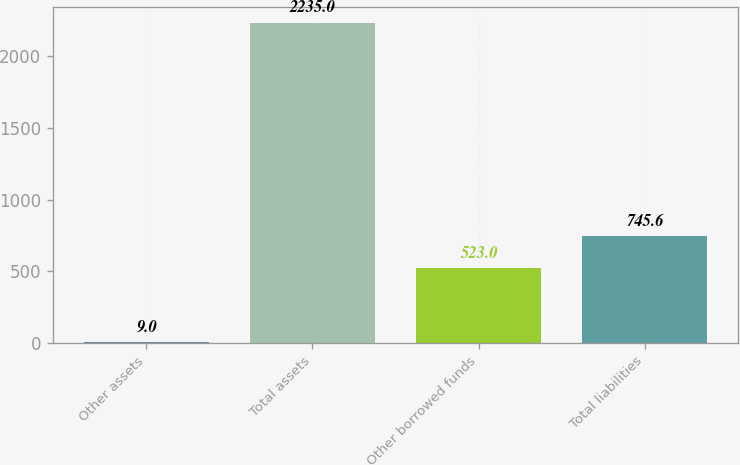Convert chart to OTSL. <chart><loc_0><loc_0><loc_500><loc_500><bar_chart><fcel>Other assets<fcel>Total assets<fcel>Other borrowed funds<fcel>Total liabilities<nl><fcel>9<fcel>2235<fcel>523<fcel>745.6<nl></chart> 